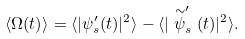<formula> <loc_0><loc_0><loc_500><loc_500>\langle \Omega ( t ) \rangle = \langle | \psi ^ { \prime } _ { s } ( t ) | ^ { 2 } \rangle - \langle | \stackrel { \sim } { \psi } ^ { \prime } _ { s } ( t ) | ^ { 2 } \rangle .</formula> 